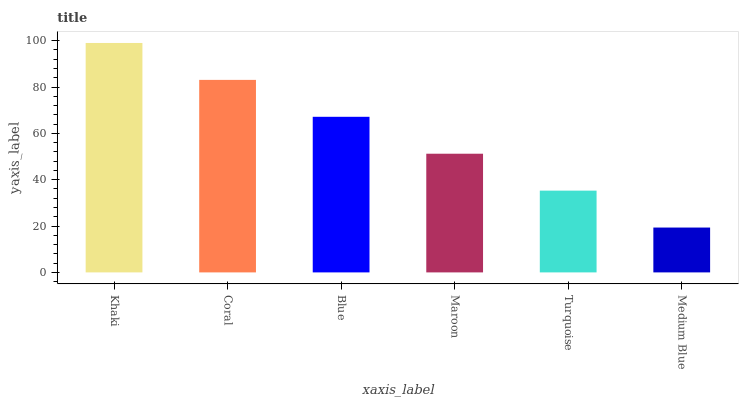Is Medium Blue the minimum?
Answer yes or no. Yes. Is Khaki the maximum?
Answer yes or no. Yes. Is Coral the minimum?
Answer yes or no. No. Is Coral the maximum?
Answer yes or no. No. Is Khaki greater than Coral?
Answer yes or no. Yes. Is Coral less than Khaki?
Answer yes or no. Yes. Is Coral greater than Khaki?
Answer yes or no. No. Is Khaki less than Coral?
Answer yes or no. No. Is Blue the high median?
Answer yes or no. Yes. Is Maroon the low median?
Answer yes or no. Yes. Is Turquoise the high median?
Answer yes or no. No. Is Khaki the low median?
Answer yes or no. No. 